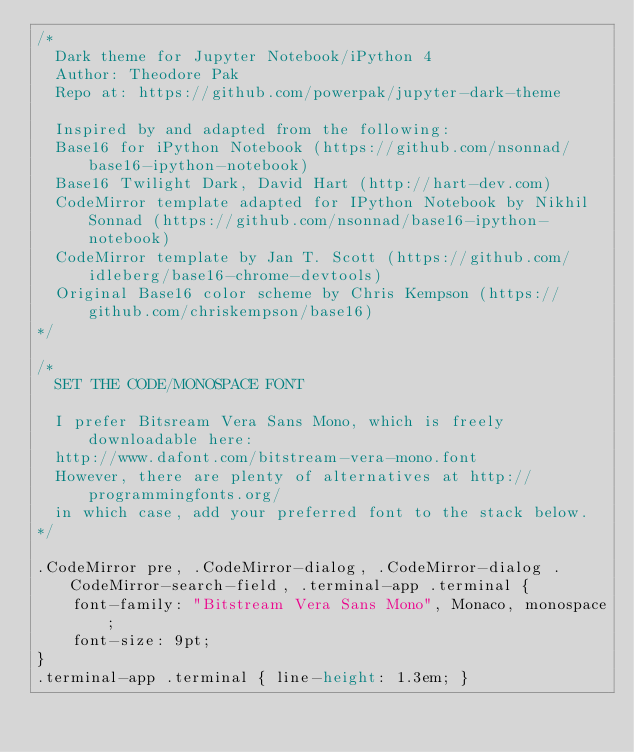<code> <loc_0><loc_0><loc_500><loc_500><_CSS_>/*
  Dark theme for Jupyter Notebook/iPython 4
  Author: Theodore Pak
  Repo at: https://github.com/powerpak/jupyter-dark-theme

  Inspired by and adapted from the following:
  Base16 for iPython Notebook (https://github.com/nsonnad/base16-ipython-notebook)
  Base16 Twilight Dark, David Hart (http://hart-dev.com)
  CodeMirror template adapted for IPython Notebook by Nikhil Sonnad (https://github.com/nsonnad/base16-ipython-notebook)
  CodeMirror template by Jan T. Scott (https://github.com/idleberg/base16-chrome-devtools)
  Original Base16 color scheme by Chris Kempson (https://github.com/chriskempson/base16)
*/

/*
  SET THE CODE/MONOSPACE FONT

  I prefer Bitsream Vera Sans Mono, which is freely downloadable here:
  http://www.dafont.com/bitstream-vera-mono.font
  However, there are plenty of alternatives at http://programmingfonts.org/
  in which case, add your preferred font to the stack below.
*/

.CodeMirror pre, .CodeMirror-dialog, .CodeMirror-dialog .CodeMirror-search-field, .terminal-app .terminal {
    font-family: "Bitstream Vera Sans Mono", Monaco, monospace;
    font-size: 9pt;
}
.terminal-app .terminal { line-height: 1.3em; }</code> 